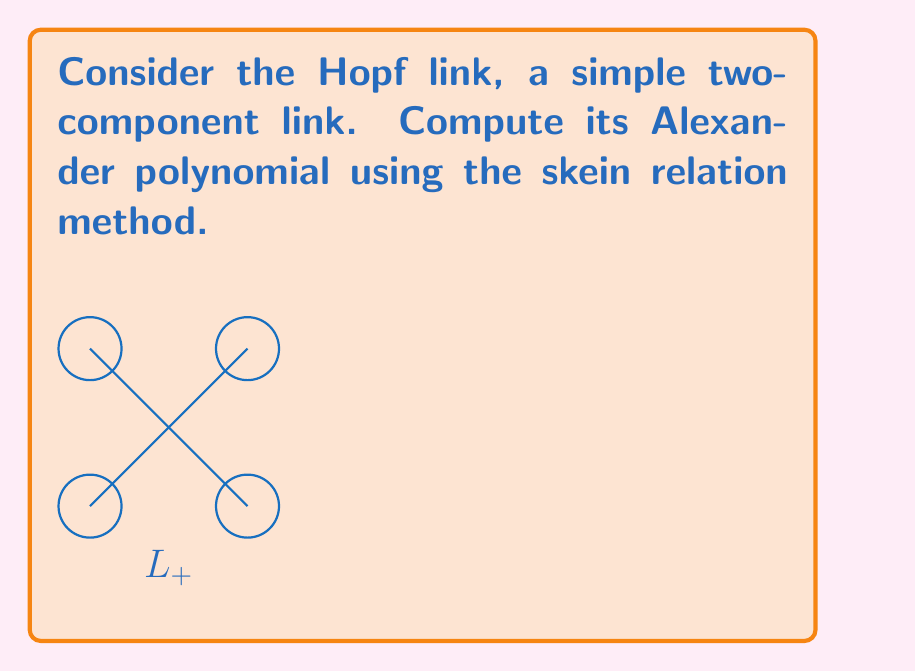Solve this math problem. Let's approach this step-by-step:

1) The skein relation for the Alexander polynomial is:
   
   $$t^{1/2}\Delta(L_+) - t^{-1/2}\Delta(L_-) = (t^{1/2} - t^{-1/2})\Delta(L_0)$$

2) For the Hopf link (L+), L- is the unlink of two components, and L0 is a single unknot.

3) We know that:
   - $\Delta(\text{unlink}) = 0$
   - $\Delta(\text{unknot}) = 1$

4) Substituting these into the skein relation:

   $$t^{1/2}\Delta(L_+) - t^{-1/2} \cdot 0 = (t^{1/2} - t^{-1/2}) \cdot 1$$

5) Simplifying:

   $$t^{1/2}\Delta(L_+) = t^{1/2} - t^{-1/2}$$

6) Dividing both sides by $t^{1/2}$:

   $$\Delta(L_+) = 1 - t^{-1}$$

7) The Alexander polynomial is typically normalized so that the lowest degree term is positive. In this case, we multiply by $-t$:

   $$\Delta(L_+) = t - 1$$

Thus, the Alexander polynomial of the Hopf link is $t - 1$.
Answer: $t - 1$ 